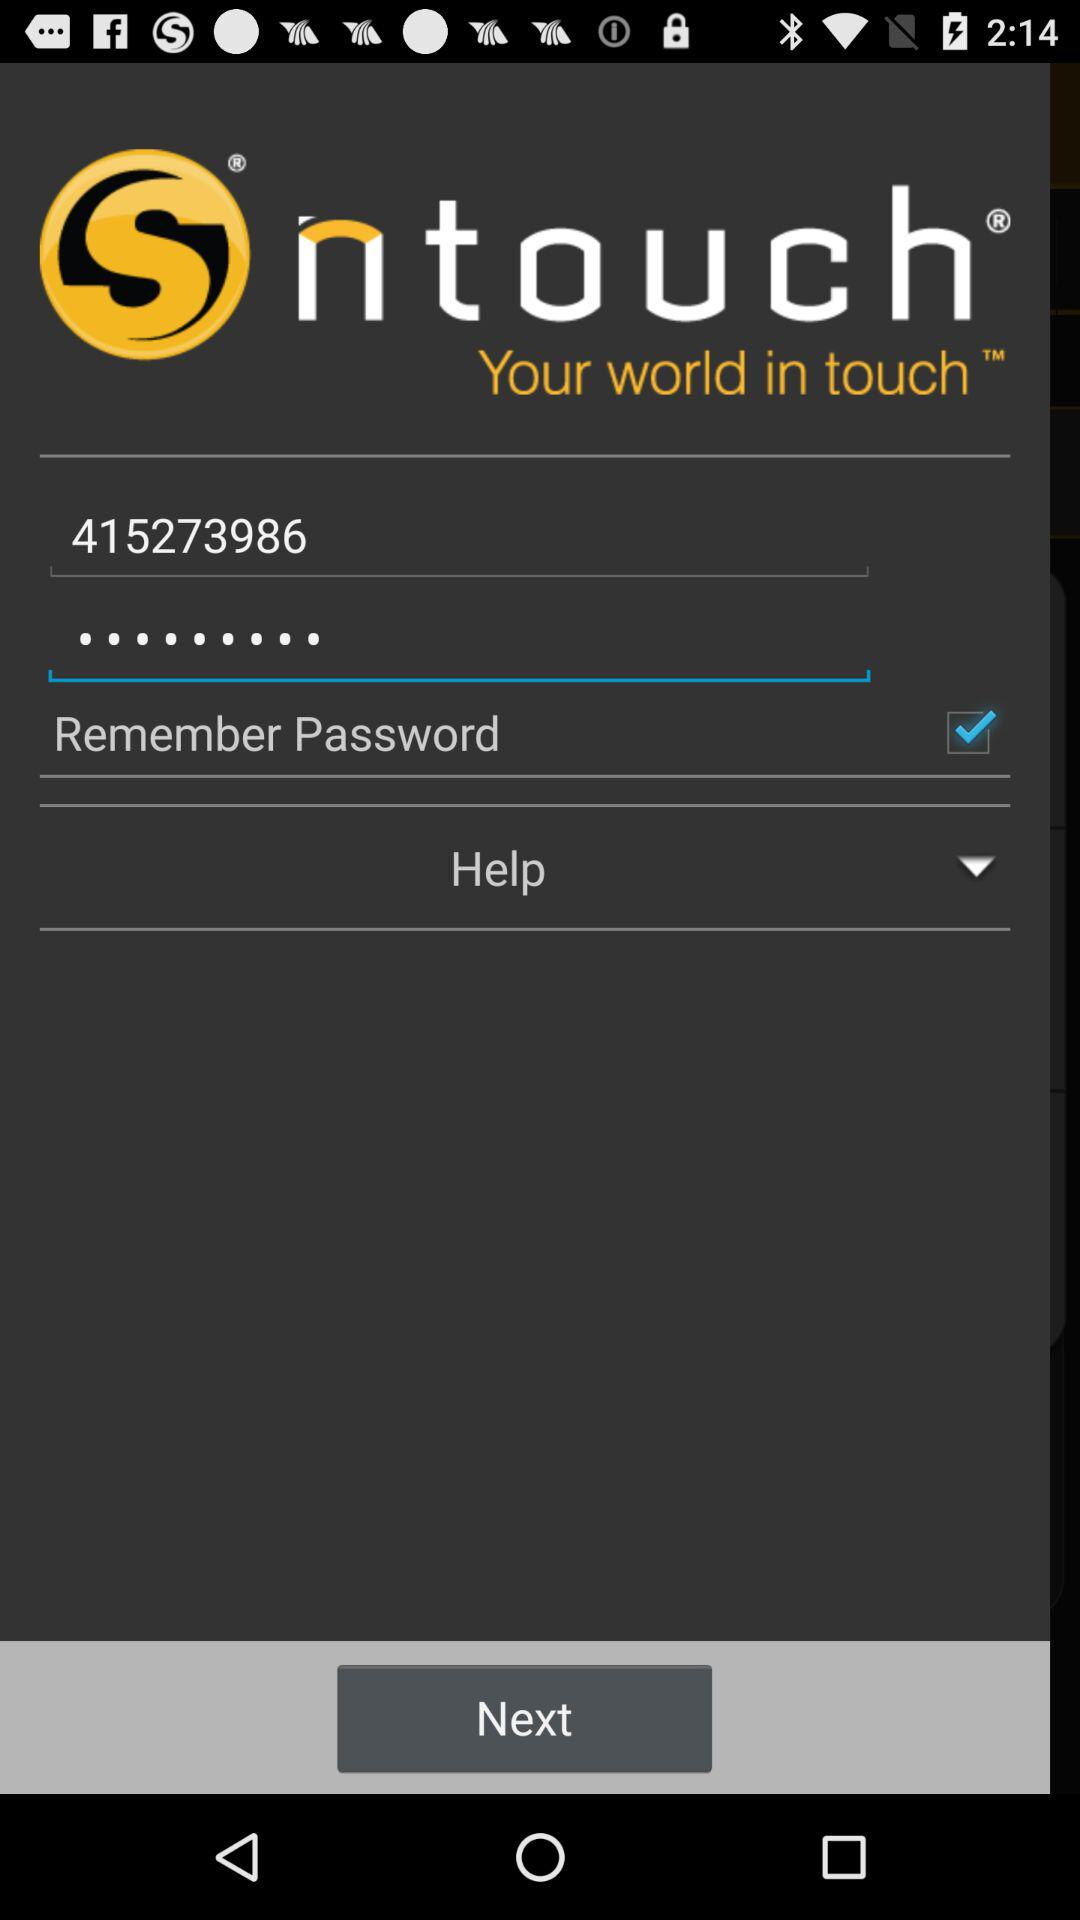Which help options are available in the drop-down menu?
When the provided information is insufficient, respond with <no answer>. <no answer> 